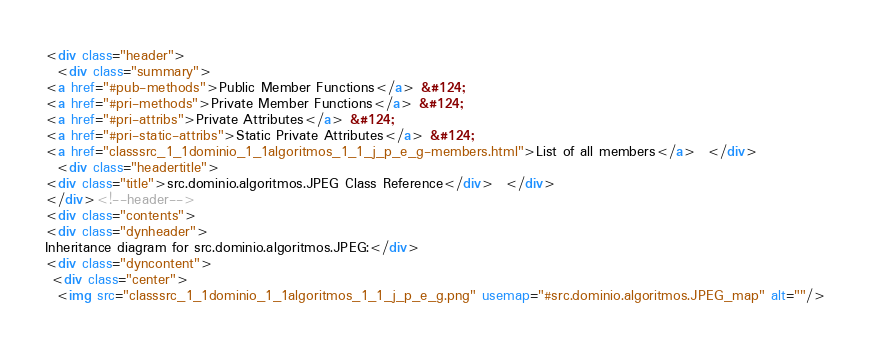<code> <loc_0><loc_0><loc_500><loc_500><_HTML_><div class="header">
  <div class="summary">
<a href="#pub-methods">Public Member Functions</a> &#124;
<a href="#pri-methods">Private Member Functions</a> &#124;
<a href="#pri-attribs">Private Attributes</a> &#124;
<a href="#pri-static-attribs">Static Private Attributes</a> &#124;
<a href="classsrc_1_1dominio_1_1algoritmos_1_1_j_p_e_g-members.html">List of all members</a>  </div>
  <div class="headertitle">
<div class="title">src.dominio.algoritmos.JPEG Class Reference</div>  </div>
</div><!--header-->
<div class="contents">
<div class="dynheader">
Inheritance diagram for src.dominio.algoritmos.JPEG:</div>
<div class="dyncontent">
 <div class="center">
  <img src="classsrc_1_1dominio_1_1algoritmos_1_1_j_p_e_g.png" usemap="#src.dominio.algoritmos.JPEG_map" alt=""/></code> 